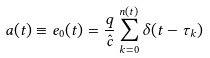Convert formula to latex. <formula><loc_0><loc_0><loc_500><loc_500>a ( t ) \equiv e _ { 0 } ( t ) = \frac { q } { \hat { c } } \sum _ { k = 0 } ^ { n ( t ) } \delta ( t - \tau _ { k } )</formula> 